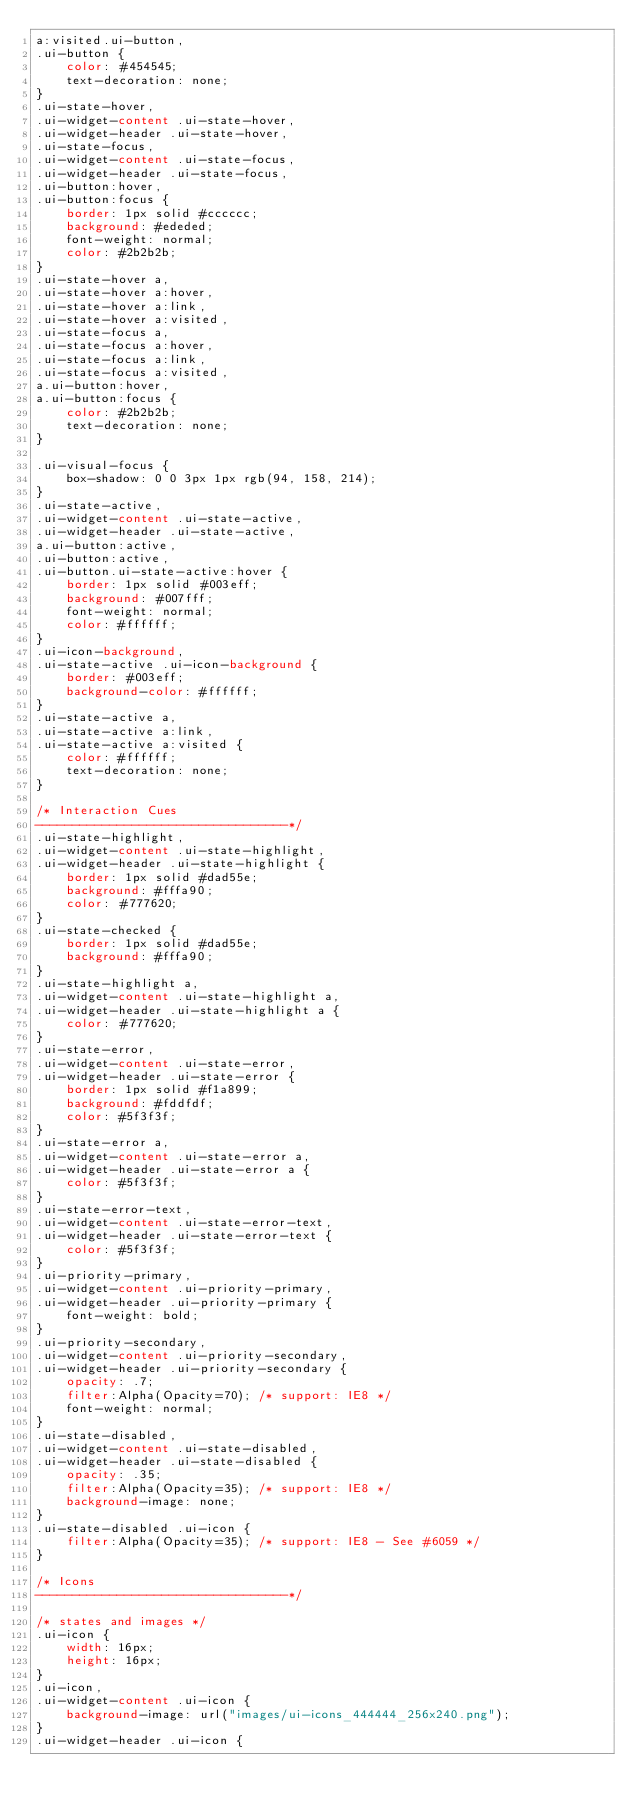<code> <loc_0><loc_0><loc_500><loc_500><_CSS_>a:visited.ui-button,
.ui-button {
	color: #454545;
	text-decoration: none;
}
.ui-state-hover,
.ui-widget-content .ui-state-hover,
.ui-widget-header .ui-state-hover,
.ui-state-focus,
.ui-widget-content .ui-state-focus,
.ui-widget-header .ui-state-focus,
.ui-button:hover,
.ui-button:focus {
	border: 1px solid #cccccc;
	background: #ededed;
	font-weight: normal;
	color: #2b2b2b;
}
.ui-state-hover a,
.ui-state-hover a:hover,
.ui-state-hover a:link,
.ui-state-hover a:visited,
.ui-state-focus a,
.ui-state-focus a:hover,
.ui-state-focus a:link,
.ui-state-focus a:visited,
a.ui-button:hover,
a.ui-button:focus {
	color: #2b2b2b;
	text-decoration: none;
}

.ui-visual-focus {
	box-shadow: 0 0 3px 1px rgb(94, 158, 214);
}
.ui-state-active,
.ui-widget-content .ui-state-active,
.ui-widget-header .ui-state-active,
a.ui-button:active,
.ui-button:active,
.ui-button.ui-state-active:hover {
	border: 1px solid #003eff;
	background: #007fff;
	font-weight: normal;
	color: #ffffff;
}
.ui-icon-background,
.ui-state-active .ui-icon-background {
	border: #003eff;
	background-color: #ffffff;
}
.ui-state-active a,
.ui-state-active a:link,
.ui-state-active a:visited {
	color: #ffffff;
	text-decoration: none;
}

/* Interaction Cues
----------------------------------*/
.ui-state-highlight,
.ui-widget-content .ui-state-highlight,
.ui-widget-header .ui-state-highlight {
	border: 1px solid #dad55e;
	background: #fffa90;
	color: #777620;
}
.ui-state-checked {
	border: 1px solid #dad55e;
	background: #fffa90;
}
.ui-state-highlight a,
.ui-widget-content .ui-state-highlight a,
.ui-widget-header .ui-state-highlight a {
	color: #777620;
}
.ui-state-error,
.ui-widget-content .ui-state-error,
.ui-widget-header .ui-state-error {
	border: 1px solid #f1a899;
	background: #fddfdf;
	color: #5f3f3f;
}
.ui-state-error a,
.ui-widget-content .ui-state-error a,
.ui-widget-header .ui-state-error a {
	color: #5f3f3f;
}
.ui-state-error-text,
.ui-widget-content .ui-state-error-text,
.ui-widget-header .ui-state-error-text {
	color: #5f3f3f;
}
.ui-priority-primary,
.ui-widget-content .ui-priority-primary,
.ui-widget-header .ui-priority-primary {
	font-weight: bold;
}
.ui-priority-secondary,
.ui-widget-content .ui-priority-secondary,
.ui-widget-header .ui-priority-secondary {
	opacity: .7;
	filter:Alpha(Opacity=70); /* support: IE8 */
	font-weight: normal;
}
.ui-state-disabled,
.ui-widget-content .ui-state-disabled,
.ui-widget-header .ui-state-disabled {
	opacity: .35;
	filter:Alpha(Opacity=35); /* support: IE8 */
	background-image: none;
}
.ui-state-disabled .ui-icon {
	filter:Alpha(Opacity=35); /* support: IE8 - See #6059 */
}

/* Icons
----------------------------------*/

/* states and images */
.ui-icon {
	width: 16px;
	height: 16px;
}
.ui-icon,
.ui-widget-content .ui-icon {
	background-image: url("images/ui-icons_444444_256x240.png");
}
.ui-widget-header .ui-icon {</code> 